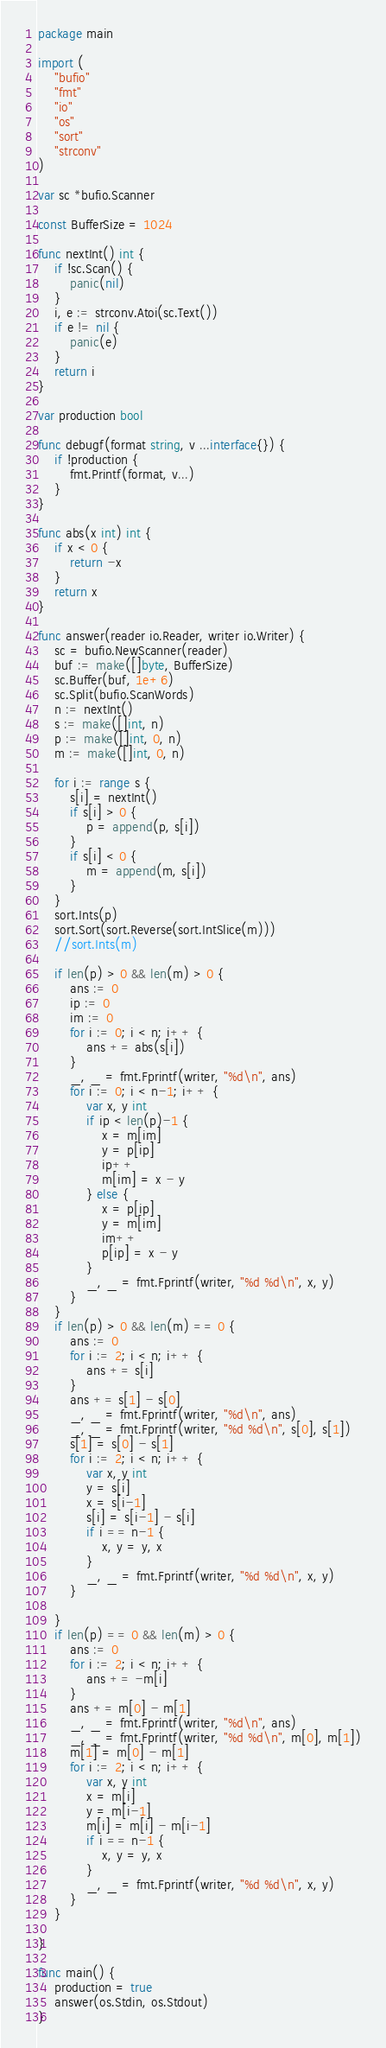<code> <loc_0><loc_0><loc_500><loc_500><_Go_>package main

import (
	"bufio"
	"fmt"
	"io"
	"os"
	"sort"
	"strconv"
)

var sc *bufio.Scanner

const BufferSize = 1024

func nextInt() int {
	if !sc.Scan() {
		panic(nil)
	}
	i, e := strconv.Atoi(sc.Text())
	if e != nil {
		panic(e)
	}
	return i
}

var production bool

func debugf(format string, v ...interface{}) {
	if !production {
		fmt.Printf(format, v...)
	}
}

func abs(x int) int {
	if x < 0 {
		return -x
	}
	return x
}

func answer(reader io.Reader, writer io.Writer) {
	sc = bufio.NewScanner(reader)
	buf := make([]byte, BufferSize)
	sc.Buffer(buf, 1e+6)
	sc.Split(bufio.ScanWords)
	n := nextInt()
	s := make([]int, n)
	p := make([]int, 0, n)
	m := make([]int, 0, n)

	for i := range s {
		s[i] = nextInt()
		if s[i] > 0 {
			p = append(p, s[i])
		}
		if s[i] < 0 {
			m = append(m, s[i])
		}
	}
	sort.Ints(p)
	sort.Sort(sort.Reverse(sort.IntSlice(m)))
	//sort.Ints(m)

	if len(p) > 0 && len(m) > 0 {
		ans := 0
		ip := 0
		im := 0
		for i := 0; i < n; i++ {
			ans += abs(s[i])
		}
		_, _ = fmt.Fprintf(writer, "%d\n", ans)
		for i := 0; i < n-1; i++ {
			var x, y int
			if ip < len(p)-1 {
				x = m[im]
				y = p[ip]
				ip++
				m[im] = x - y
			} else {
				x = p[ip]
				y = m[im]
				im++
				p[ip] = x - y
			}
			_, _ = fmt.Fprintf(writer, "%d %d\n", x, y)
		}
	}
	if len(p) > 0 && len(m) == 0 {
		ans := 0
		for i := 2; i < n; i++ {
			ans += s[i]
		}
		ans += s[1] - s[0]
		_, _ = fmt.Fprintf(writer, "%d\n", ans)
		_, _ = fmt.Fprintf(writer, "%d %d\n", s[0], s[1])
		s[1] = s[0] - s[1]
		for i := 2; i < n; i++ {
			var x, y int
			y = s[i]
			x = s[i-1]
			s[i] = s[i-1] - s[i]
			if i == n-1 {
				x, y = y, x
			}
			_, _ = fmt.Fprintf(writer, "%d %d\n", x, y)
		}

	}
	if len(p) == 0 && len(m) > 0 {
		ans := 0
		for i := 2; i < n; i++ {
			ans += -m[i]
		}
		ans += m[0] - m[1]
		_, _ = fmt.Fprintf(writer, "%d\n", ans)
		_, _ = fmt.Fprintf(writer, "%d %d\n", m[0], m[1])
		m[1] = m[0] - m[1]
		for i := 2; i < n; i++ {
			var x, y int
			x = m[i]
			y = m[i-1]
			m[i] = m[i] - m[i-1]
			if i == n-1 {
				x, y = y, x
			}
			_, _ = fmt.Fprintf(writer, "%d %d\n", x, y)
		}
	}

}

func main() {
	production = true
	answer(os.Stdin, os.Stdout)
}
</code> 